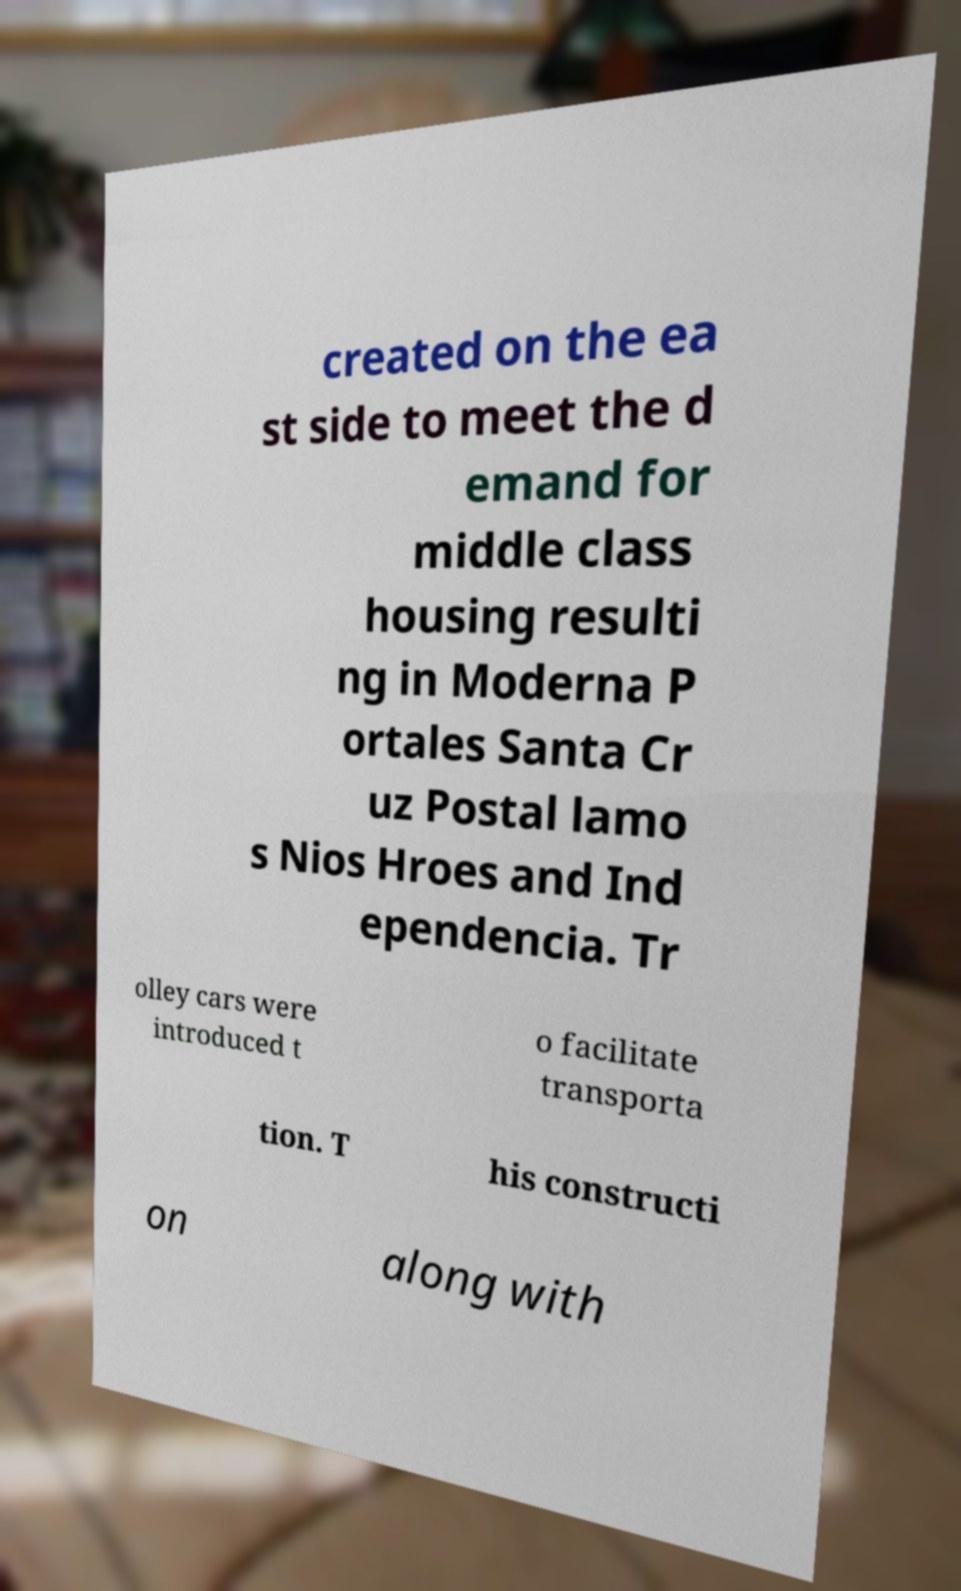Please read and relay the text visible in this image. What does it say? created on the ea st side to meet the d emand for middle class housing resulti ng in Moderna P ortales Santa Cr uz Postal lamo s Nios Hroes and Ind ependencia. Tr olley cars were introduced t o facilitate transporta tion. T his constructi on along with 